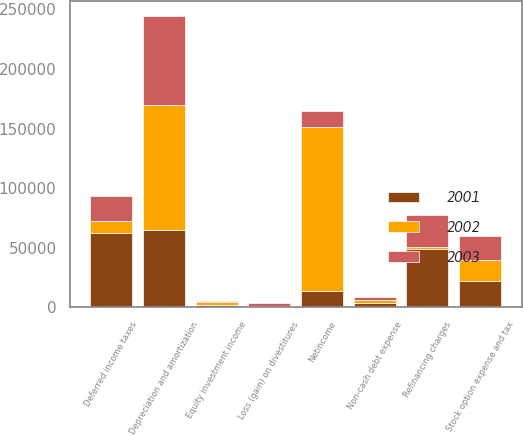Convert chart to OTSL. <chart><loc_0><loc_0><loc_500><loc_500><stacked_bar_chart><ecel><fcel>Netincome<fcel>Depreciation and amortization<fcel>Refinancing charges<fcel>Loss (gain) on divestitures<fcel>Deferred income taxes<fcel>Non-cash debt expense<fcel>Stock option expense and tax<fcel>Equity investment income<nl><fcel>2003<fcel>13923.5<fcel>74687<fcel>26501<fcel>2130<fcel>20914<fcel>3124<fcel>20180<fcel>1596<nl><fcel>2001<fcel>13923.5<fcel>64665<fcel>48930<fcel>1151<fcel>62172<fcel>3217<fcel>22212<fcel>1791<nl><fcel>2002<fcel>137315<fcel>105209<fcel>1629<fcel>71<fcel>10093<fcel>2396<fcel>17754<fcel>2126<nl></chart> 